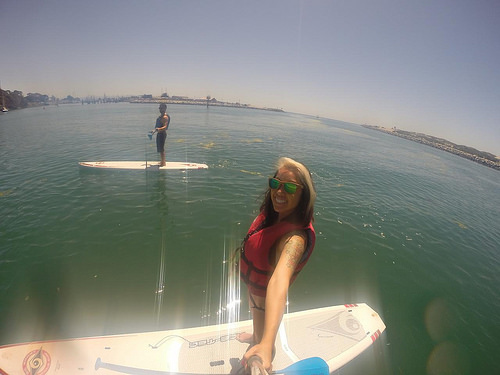<image>
Is the life jacket on the water? No. The life jacket is not positioned on the water. They may be near each other, but the life jacket is not supported by or resting on top of the water. Is the woman under the sea? No. The woman is not positioned under the sea. The vertical relationship between these objects is different. Where is the surfboard in relation to the water? Is it in the water? Yes. The surfboard is contained within or inside the water, showing a containment relationship. 